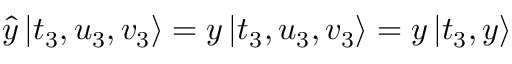<formula> <loc_0><loc_0><loc_500><loc_500>\begin{array} { r } { \hat { y } \left | t _ { 3 } , u _ { 3 } , v _ { 3 } \right \rangle = y \left | t _ { 3 } , u _ { 3 } , v _ { 3 } \right \rangle = y \left | t _ { 3 } , y \right \rangle } \end{array}</formula> 